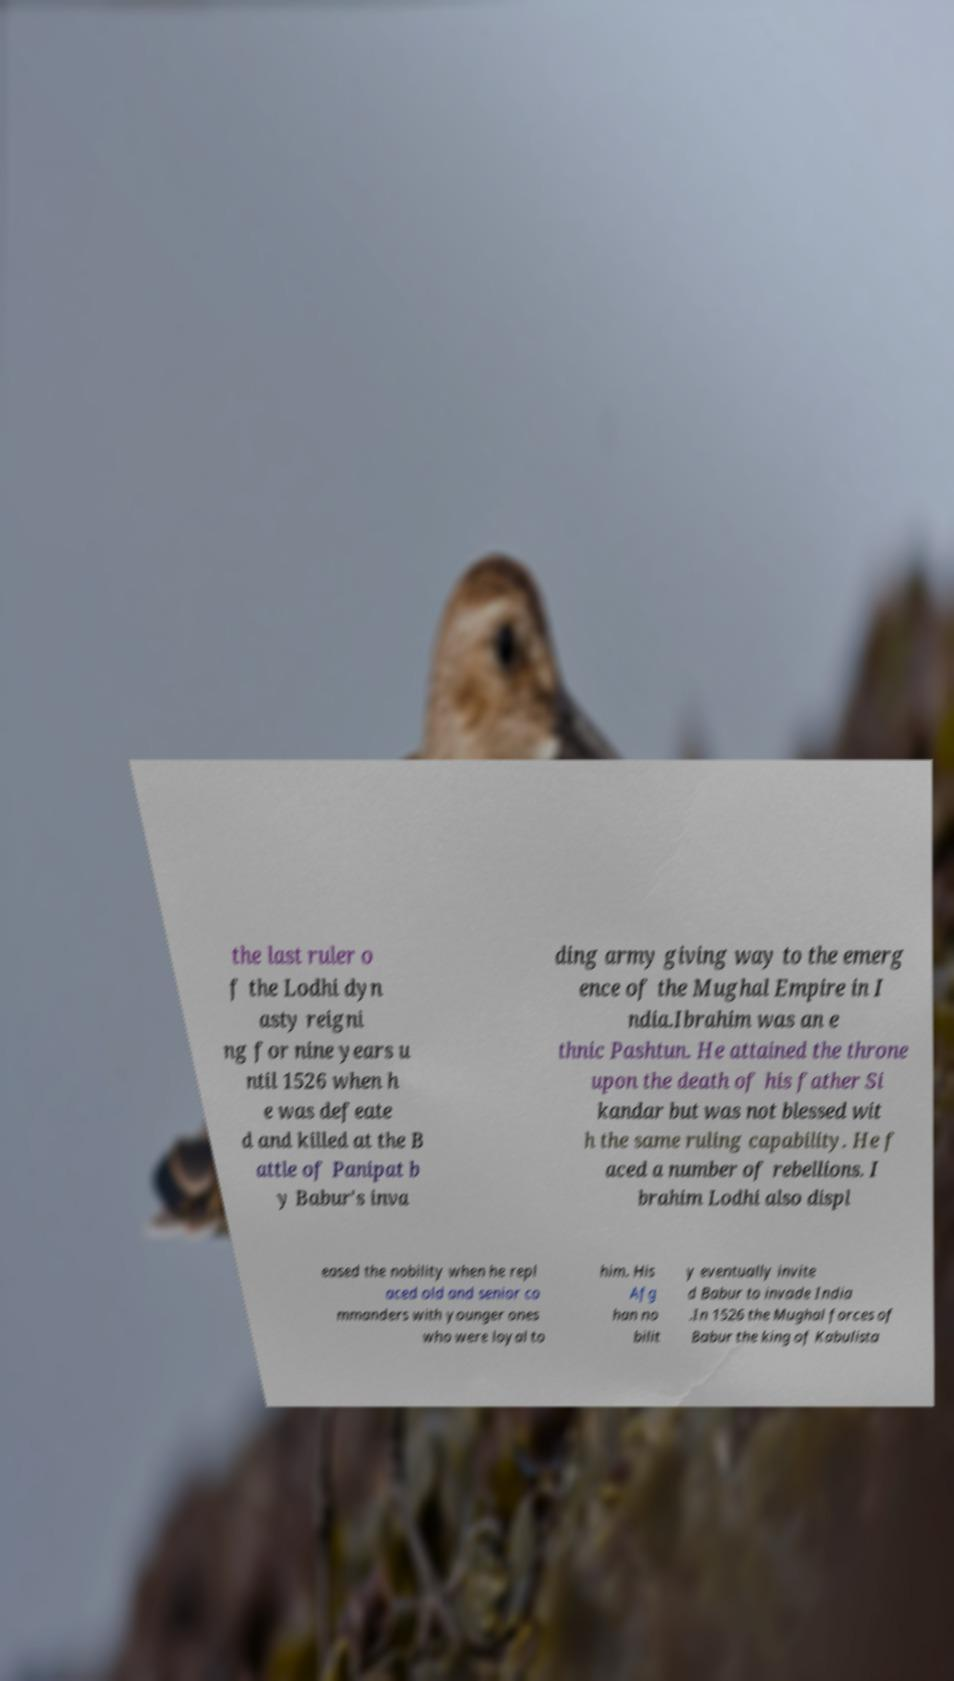For documentation purposes, I need the text within this image transcribed. Could you provide that? the last ruler o f the Lodhi dyn asty reigni ng for nine years u ntil 1526 when h e was defeate d and killed at the B attle of Panipat b y Babur's inva ding army giving way to the emerg ence of the Mughal Empire in I ndia.Ibrahim was an e thnic Pashtun. He attained the throne upon the death of his father Si kandar but was not blessed wit h the same ruling capability. He f aced a number of rebellions. I brahim Lodhi also displ eased the nobility when he repl aced old and senior co mmanders with younger ones who were loyal to him. His Afg han no bilit y eventually invite d Babur to invade India .In 1526 the Mughal forces of Babur the king of Kabulista 